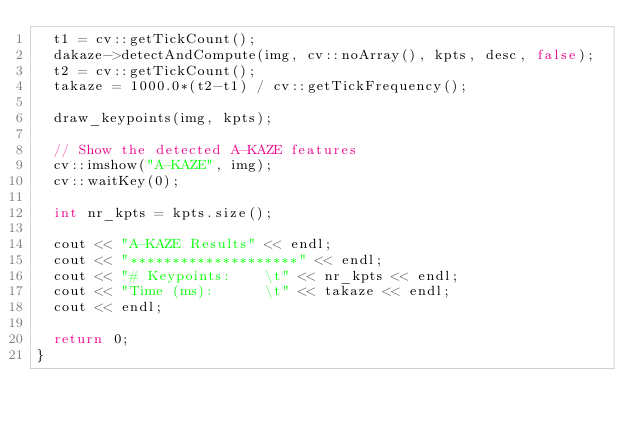<code> <loc_0><loc_0><loc_500><loc_500><_C++_>  t1 = cv::getTickCount();
  dakaze->detectAndCompute(img, cv::noArray(), kpts, desc, false);
  t2 = cv::getTickCount();
  takaze = 1000.0*(t2-t1) / cv::getTickFrequency();

  draw_keypoints(img, kpts);

  // Show the detected A-KAZE features
  cv::imshow("A-KAZE", img);
  cv::waitKey(0);

  int nr_kpts = kpts.size();

  cout << "A-KAZE Results" << endl;
  cout << "********************" << endl;
  cout << "# Keypoints:    \t" << nr_kpts << endl;
  cout << "Time (ms):      \t" << takaze << endl;
  cout << endl;

  return 0;
}
</code> 